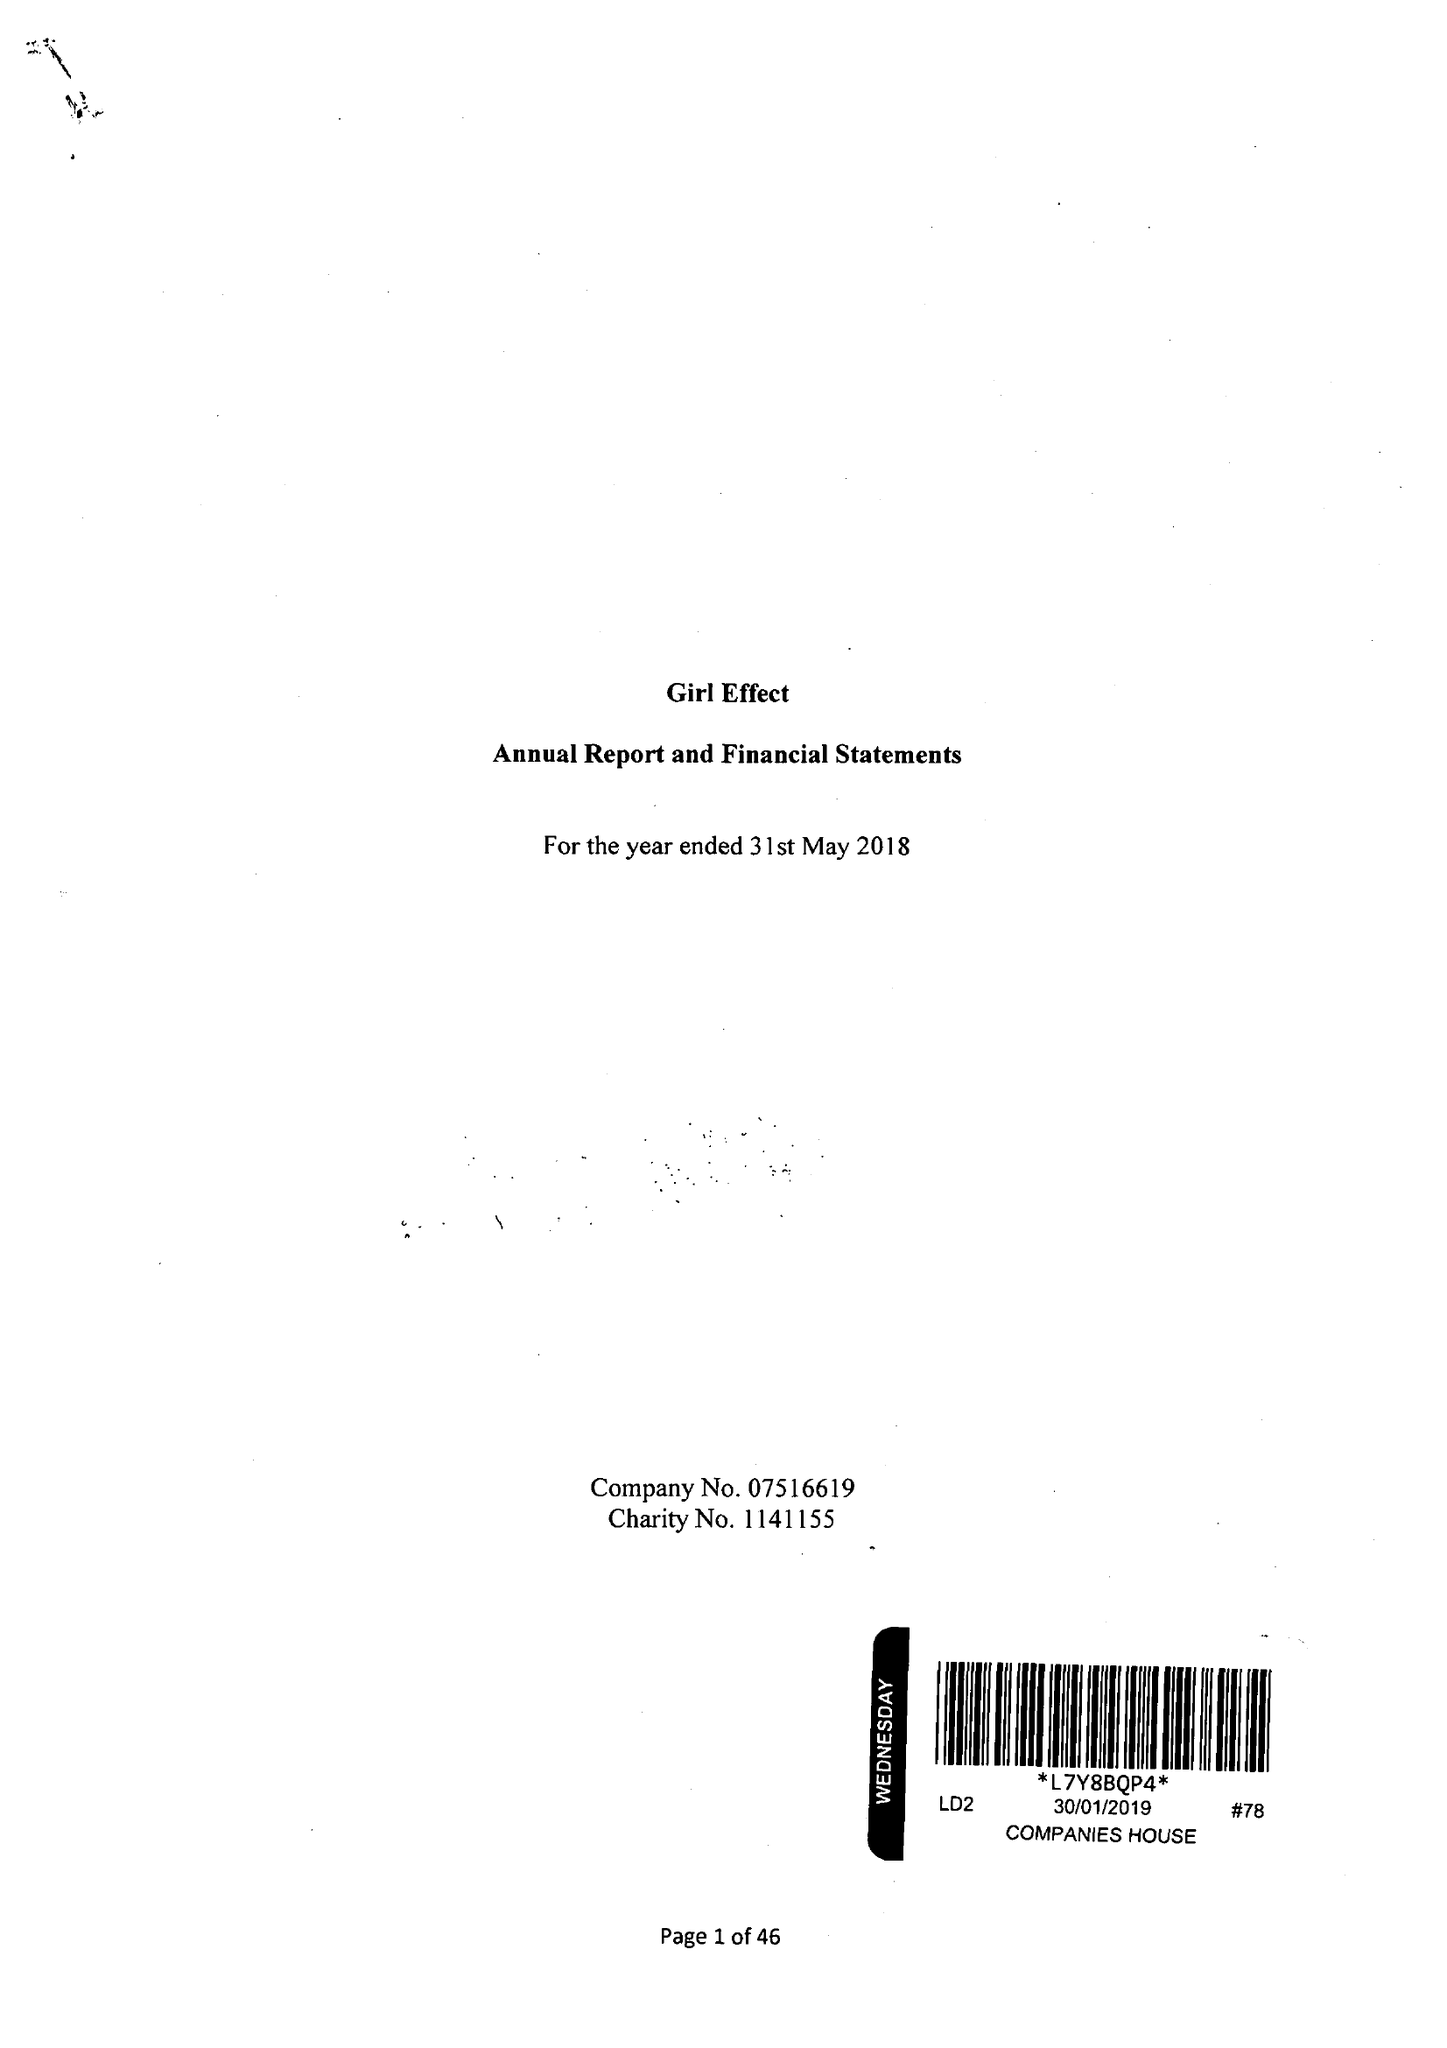What is the value for the income_annually_in_british_pounds?
Answer the question using a single word or phrase. 30380639.00 